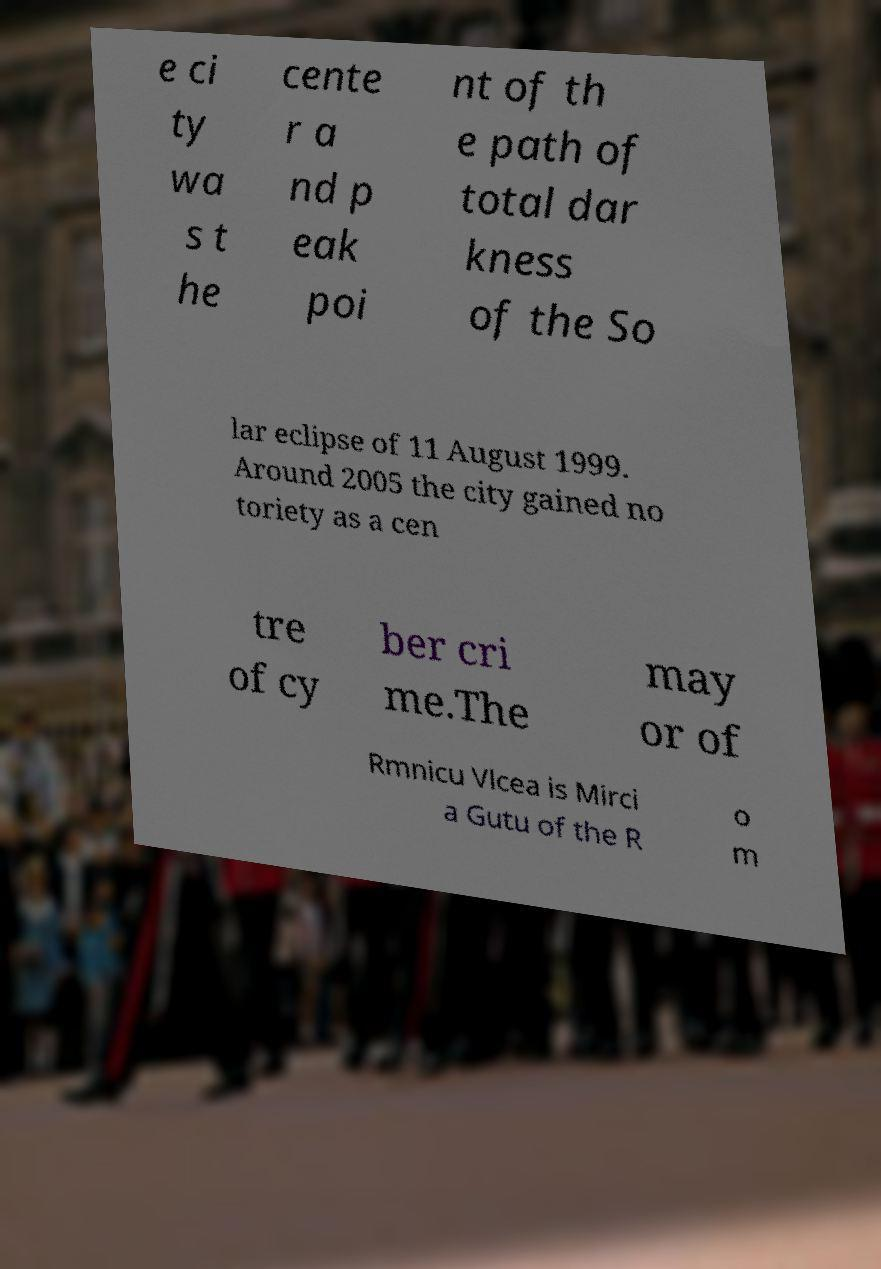Can you accurately transcribe the text from the provided image for me? e ci ty wa s t he cente r a nd p eak poi nt of th e path of total dar kness of the So lar eclipse of 11 August 1999. Around 2005 the city gained no toriety as a cen tre of cy ber cri me.The may or of Rmnicu Vlcea is Mirci a Gutu of the R o m 